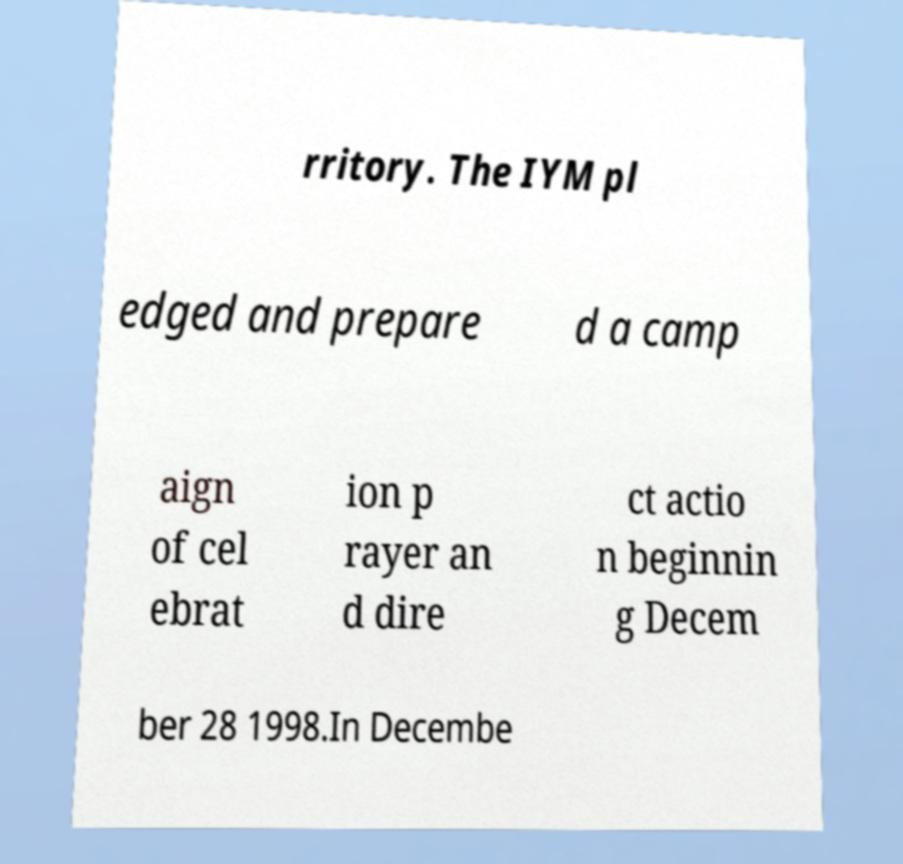For documentation purposes, I need the text within this image transcribed. Could you provide that? rritory. The IYM pl edged and prepare d a camp aign of cel ebrat ion p rayer an d dire ct actio n beginnin g Decem ber 28 1998.In Decembe 